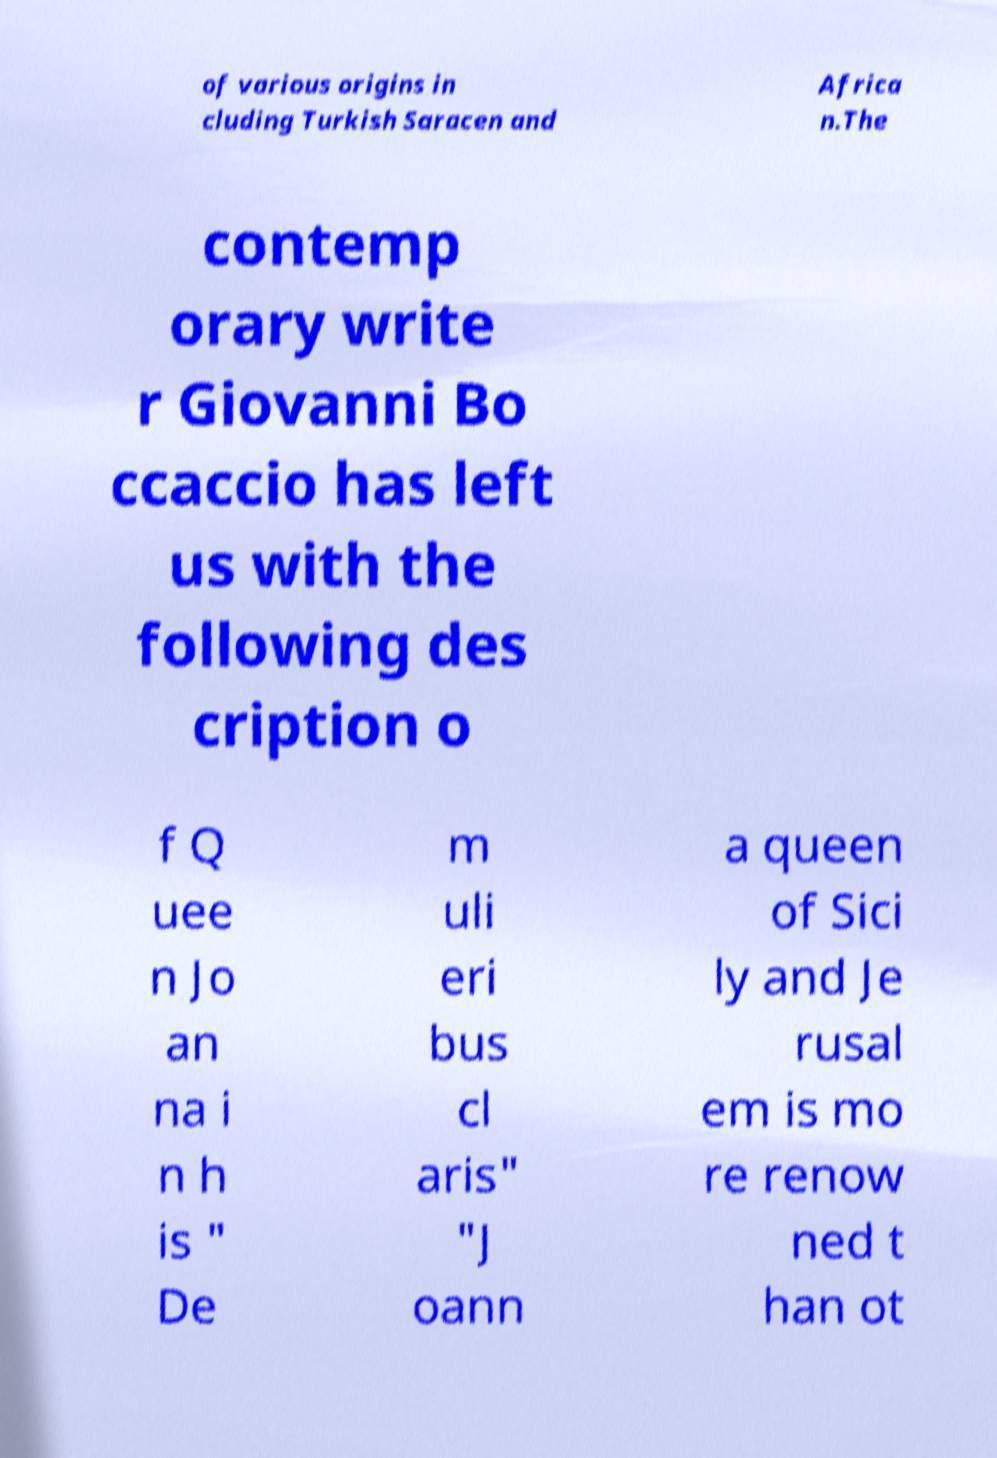Could you extract and type out the text from this image? of various origins in cluding Turkish Saracen and Africa n.The contemp orary write r Giovanni Bo ccaccio has left us with the following des cription o f Q uee n Jo an na i n h is " De m uli eri bus cl aris" "J oann a queen of Sici ly and Je rusal em is mo re renow ned t han ot 